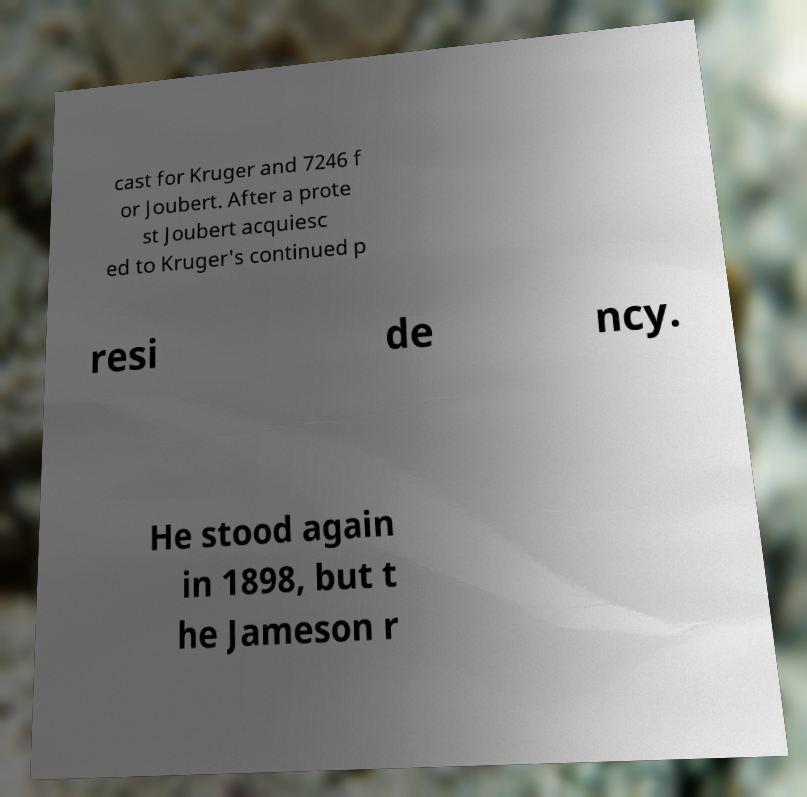Can you read and provide the text displayed in the image?This photo seems to have some interesting text. Can you extract and type it out for me? cast for Kruger and 7246 f or Joubert. After a prote st Joubert acquiesc ed to Kruger's continued p resi de ncy. He stood again in 1898, but t he Jameson r 